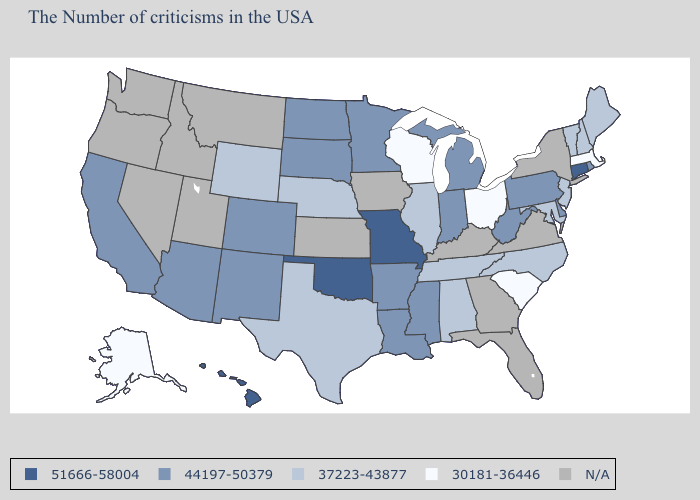What is the value of Indiana?
Keep it brief. 44197-50379. Which states have the lowest value in the Northeast?
Quick response, please. Massachusetts. What is the value of Delaware?
Be succinct. 44197-50379. Does the first symbol in the legend represent the smallest category?
Short answer required. No. Which states have the lowest value in the South?
Answer briefly. South Carolina. Among the states that border Missouri , does Illinois have the highest value?
Answer briefly. No. Does the first symbol in the legend represent the smallest category?
Keep it brief. No. What is the value of Rhode Island?
Short answer required. 44197-50379. Does Oklahoma have the highest value in the South?
Keep it brief. Yes. What is the value of Utah?
Write a very short answer. N/A. Is the legend a continuous bar?
Short answer required. No. Name the states that have a value in the range 51666-58004?
Quick response, please. Connecticut, Missouri, Oklahoma, Hawaii. What is the lowest value in the Northeast?
Keep it brief. 30181-36446. Does South Carolina have the highest value in the USA?
Be succinct. No. 